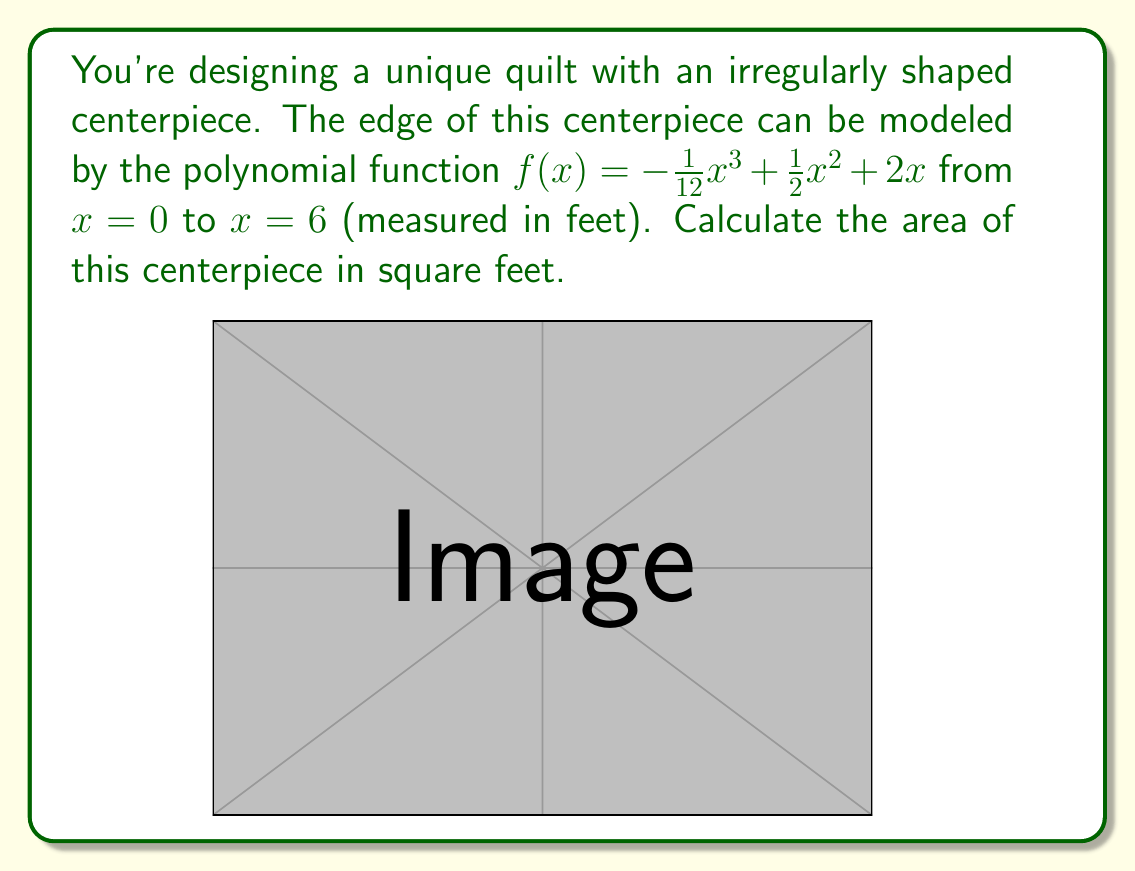Teach me how to tackle this problem. To find the area of this irregularly shaped quilt piece, we need to calculate the definite integral of the function $f(x)$ from 0 to 6. This will give us the area between the curve and the x-axis.

Step 1: Set up the integral
$$A = \int_0^6 f(x) dx = \int_0^6 (-\frac{1}{12}x^3 + \frac{1}{2}x^2 + 2x) dx$$

Step 2: Integrate the function
$$\begin{align*}
A &= \left[-\frac{1}{48}x^4 + \frac{1}{6}x^3 + x^2\right]_0^6 \\
&= \left(-\frac{1}{48}(6^4) + \frac{1}{6}(6^3) + 6^2\right) - \left(-\frac{1}{48}(0^4) + \frac{1}{6}(0^3) + 0^2\right)
\end{align*}$$

Step 3: Evaluate the expression
$$\begin{align*}
A &= \left(-\frac{1296}{48} + 36 + 36\right) - 0 \\
&= -27 + 72 \\
&= 45
\end{align*}$$

Therefore, the area of the irregularly shaped quilt centerpiece is 45 square feet.
Answer: 45 square feet 